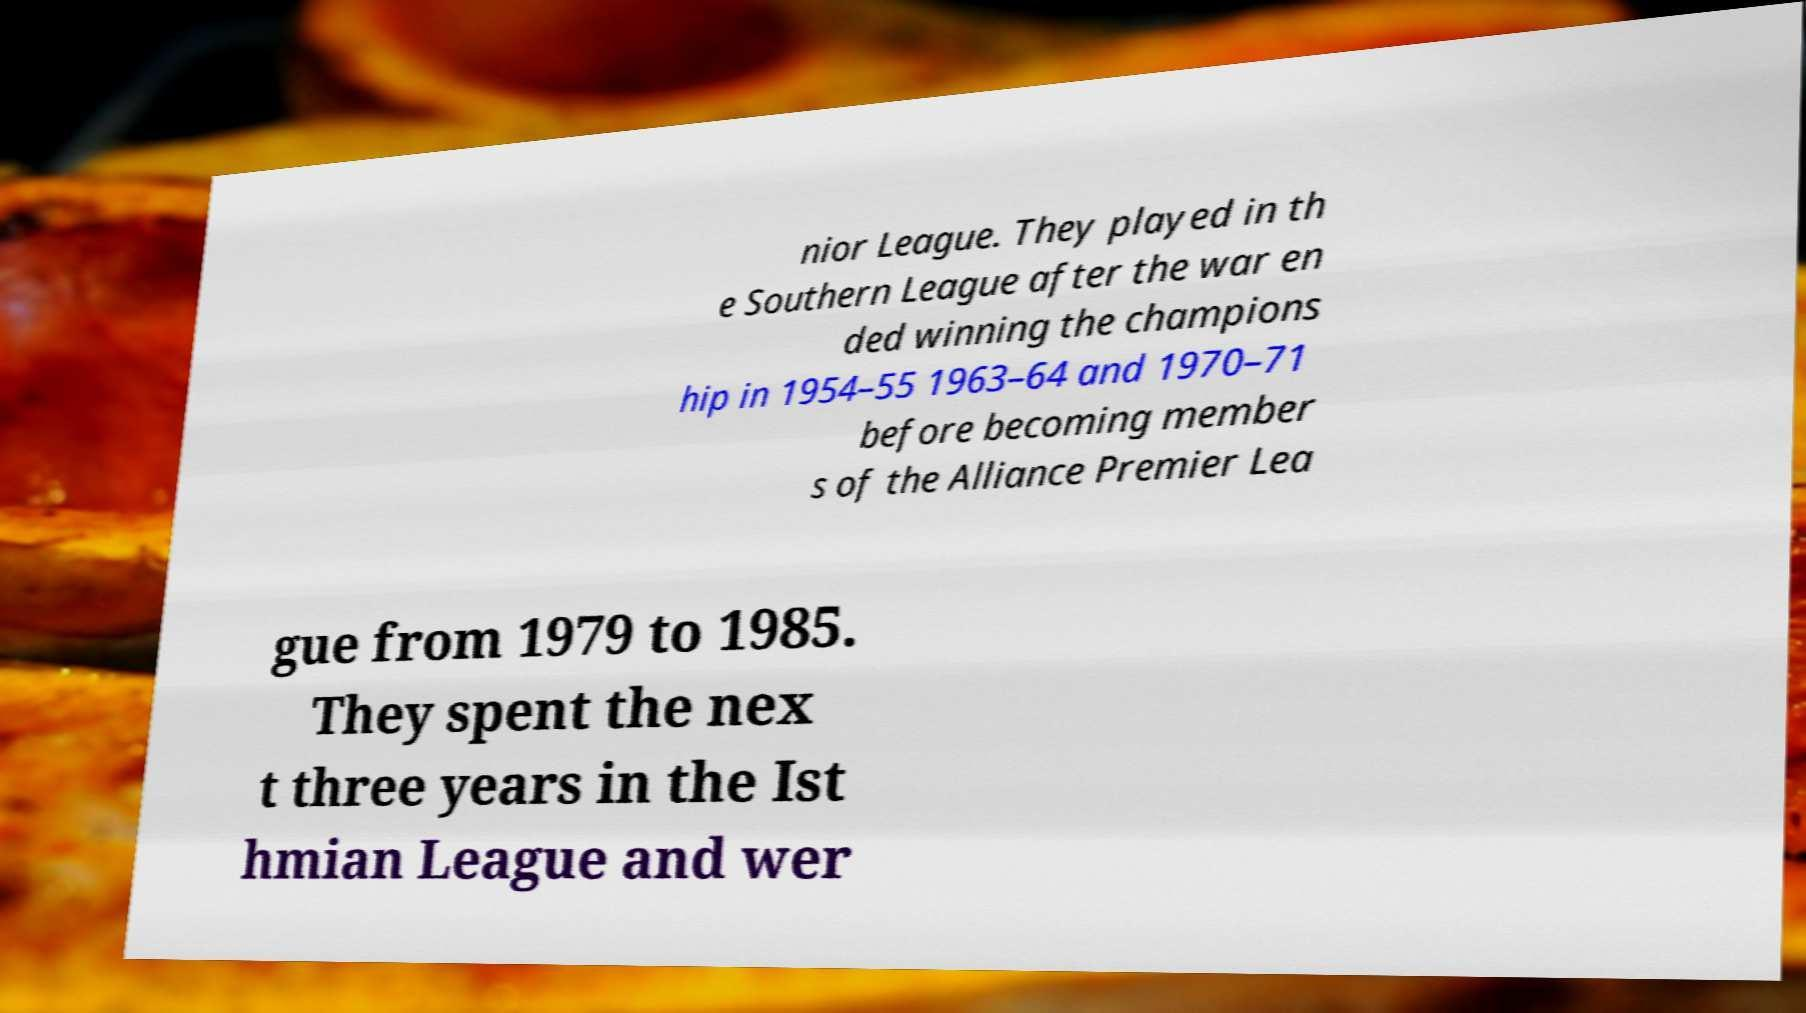Could you assist in decoding the text presented in this image and type it out clearly? nior League. They played in th e Southern League after the war en ded winning the champions hip in 1954–55 1963–64 and 1970–71 before becoming member s of the Alliance Premier Lea gue from 1979 to 1985. They spent the nex t three years in the Ist hmian League and wer 